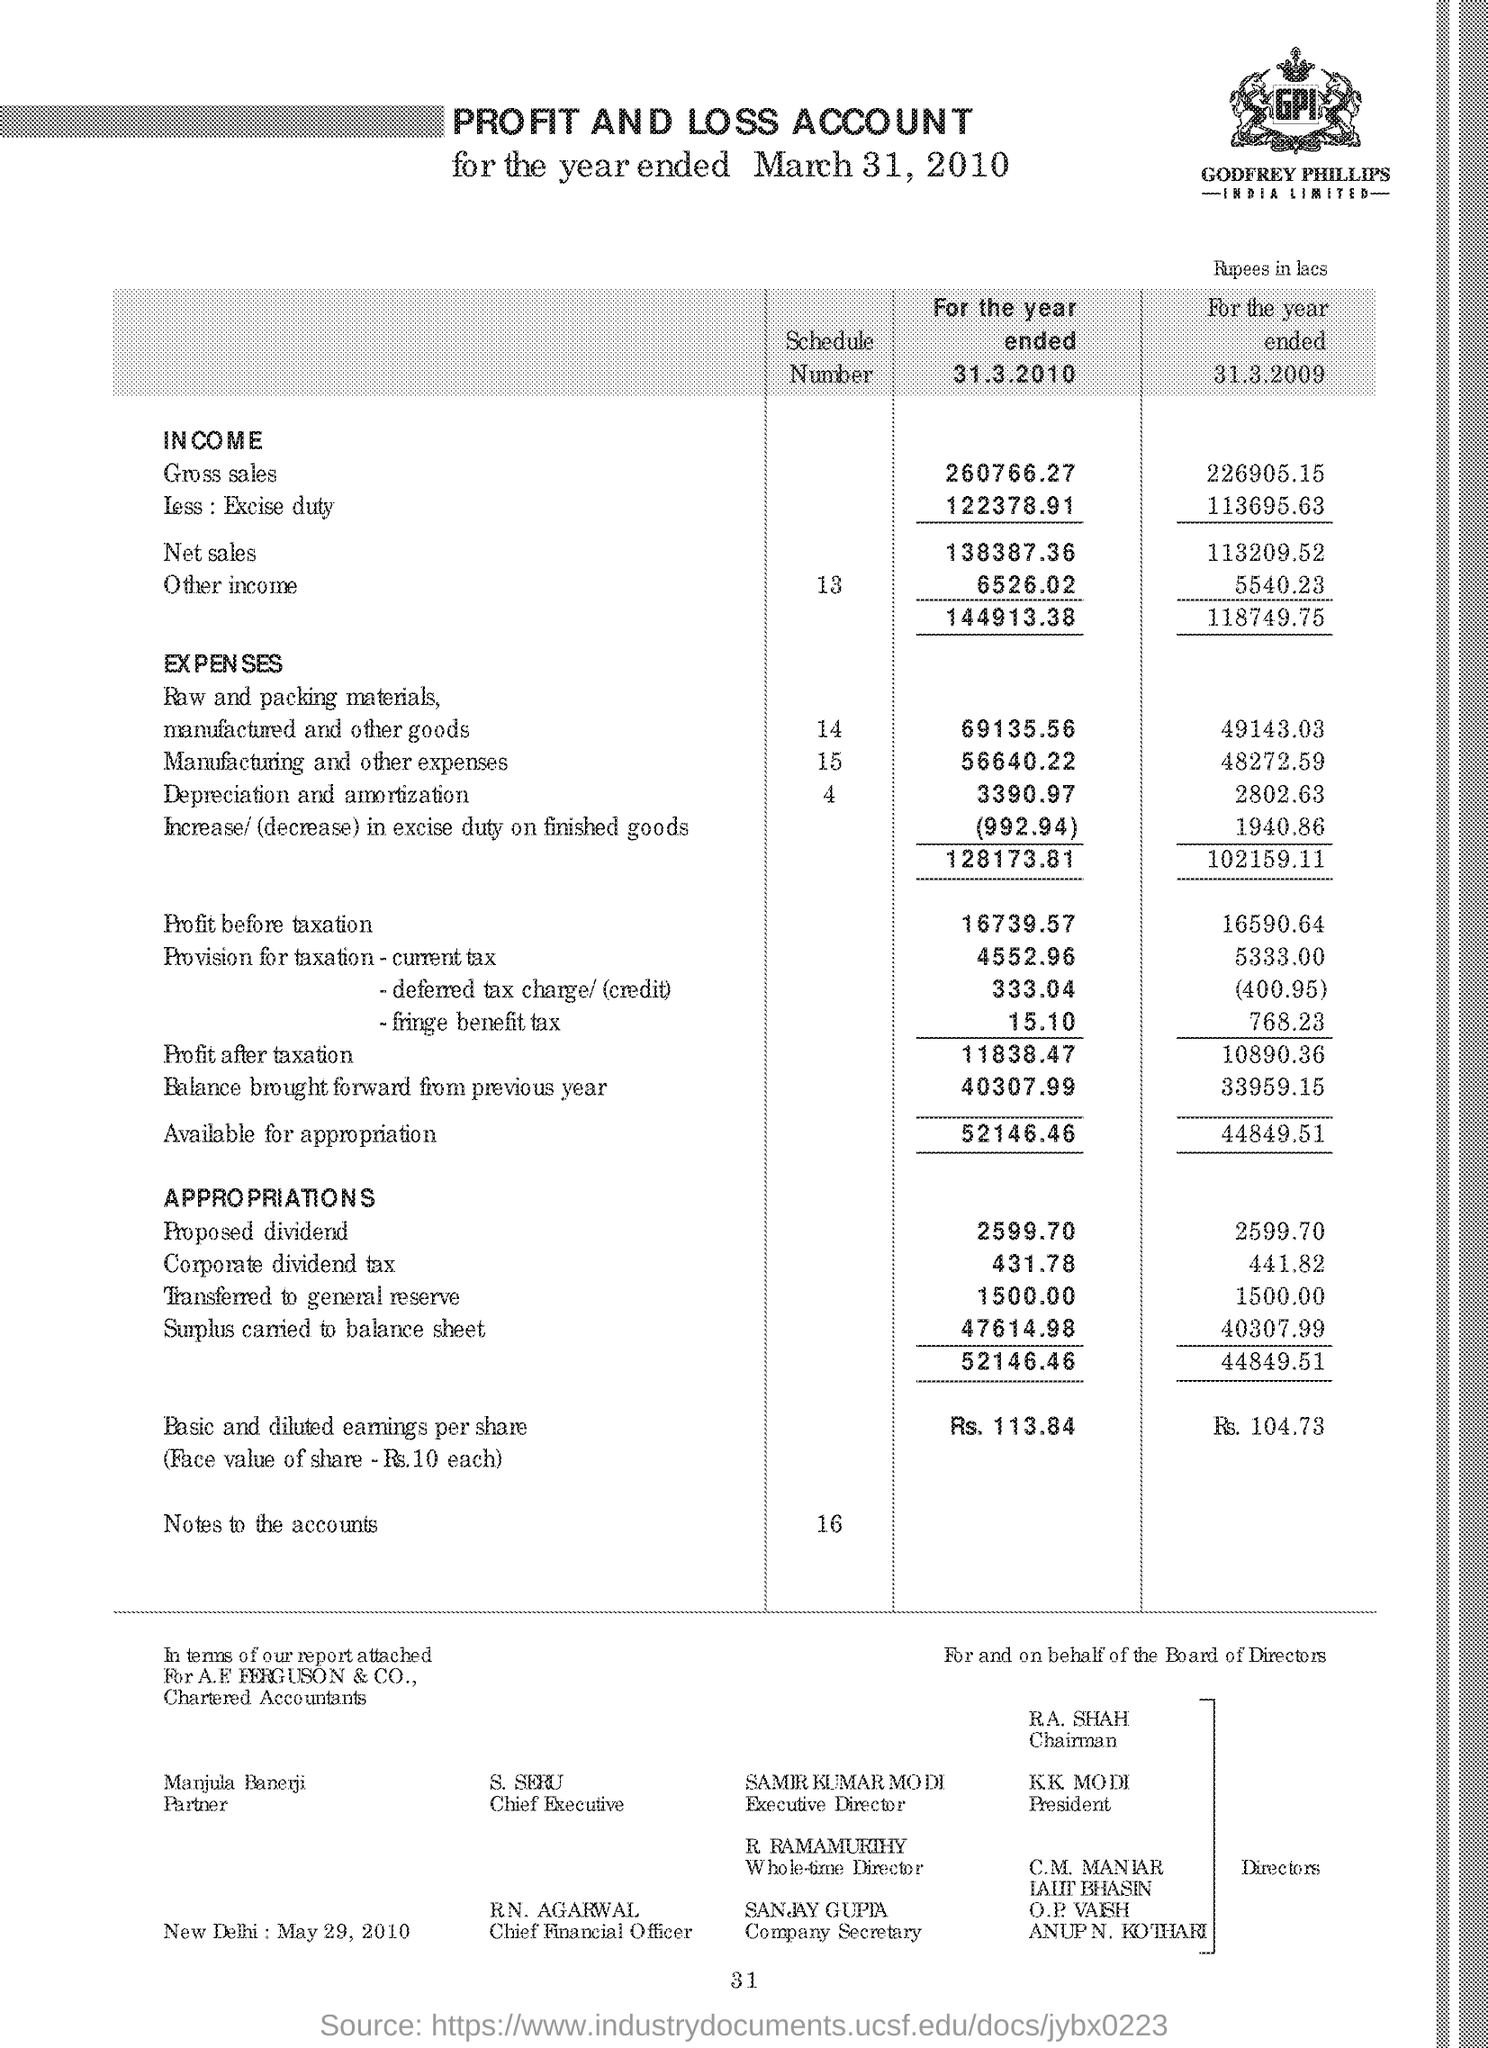Specify some key components in this picture. The company secretary is Sanjay Gupta. The gross sales for the year ended March 31, 2010, generated an income of 260,766.27. Samir Kumar Modi is the executive director. The gross sales for the year ended 31.3.2009 resulted in a total income of 226905.15. 